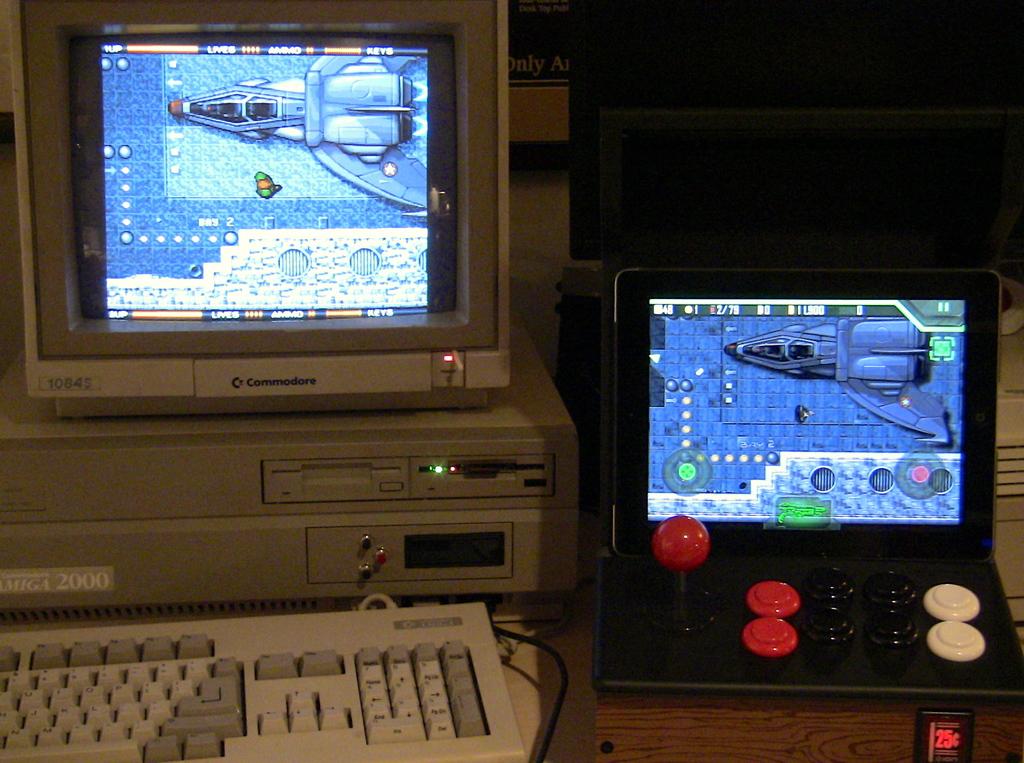What company made the computer on the left?
Offer a very short reply. Commodore. What brand is the computer monitor?
Make the answer very short. Commodore. 